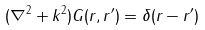Convert formula to latex. <formula><loc_0><loc_0><loc_500><loc_500>( \nabla ^ { 2 } + k ^ { 2 } ) G ( r , r ^ { \prime } ) = \delta ( r - r ^ { \prime } )</formula> 